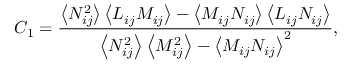<formula> <loc_0><loc_0><loc_500><loc_500>{ C _ { 1 } } = \frac { { \left \langle { N _ { i j } ^ { 2 } } \right \rangle \left \langle { { L } _ { i j } { M _ { i j } } } \right \rangle - \left \langle { { M _ { i j } } { N _ { i j } } } \right \rangle \left \langle { { L } _ { i j } { N _ { i j } } } \right \rangle } } { { \left \langle { N _ { i j } ^ { 2 } } \right \rangle \left \langle { M _ { i j } ^ { 2 } } \right \rangle - { { \left \langle { { M _ { i j } } { N _ { i j } } } \right \rangle } ^ { 2 } } } } ,</formula> 